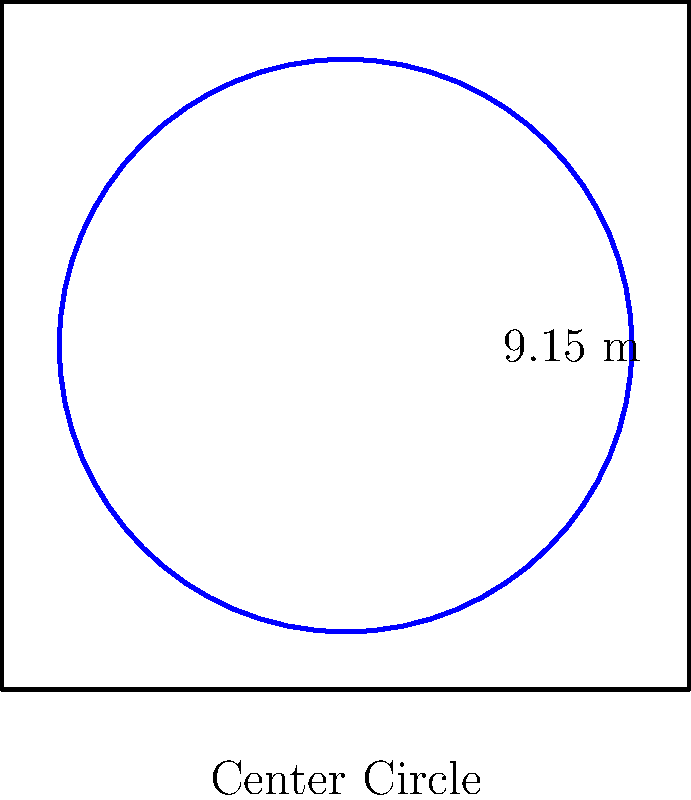In a standard football (soccer) field, the center circle has a radius of 9.15 meters. What is the perimeter of this center circle to the nearest centimeter? To find the perimeter of the center circle, we need to use the formula for the circumference of a circle:

$$C = 2\pi r$$

Where:
$C$ = circumference (perimeter)
$\pi$ = pi (approximately 3.14159)
$r$ = radius

Given:
Radius of the center circle = 9.15 meters

Step 1: Substitute the values into the formula
$$C = 2 \times \pi \times 9.15$$

Step 2: Calculate
$$C = 2 \times 3.14159 \times 9.15$$
$$C = 57.4450985 \text{ meters}$$

Step 3: Round to the nearest centimeter (2 decimal places)
$$C \approx 57.45 \text{ meters}$$

Therefore, the perimeter of the center circle is approximately 57.45 meters.
Answer: 57.45 meters 